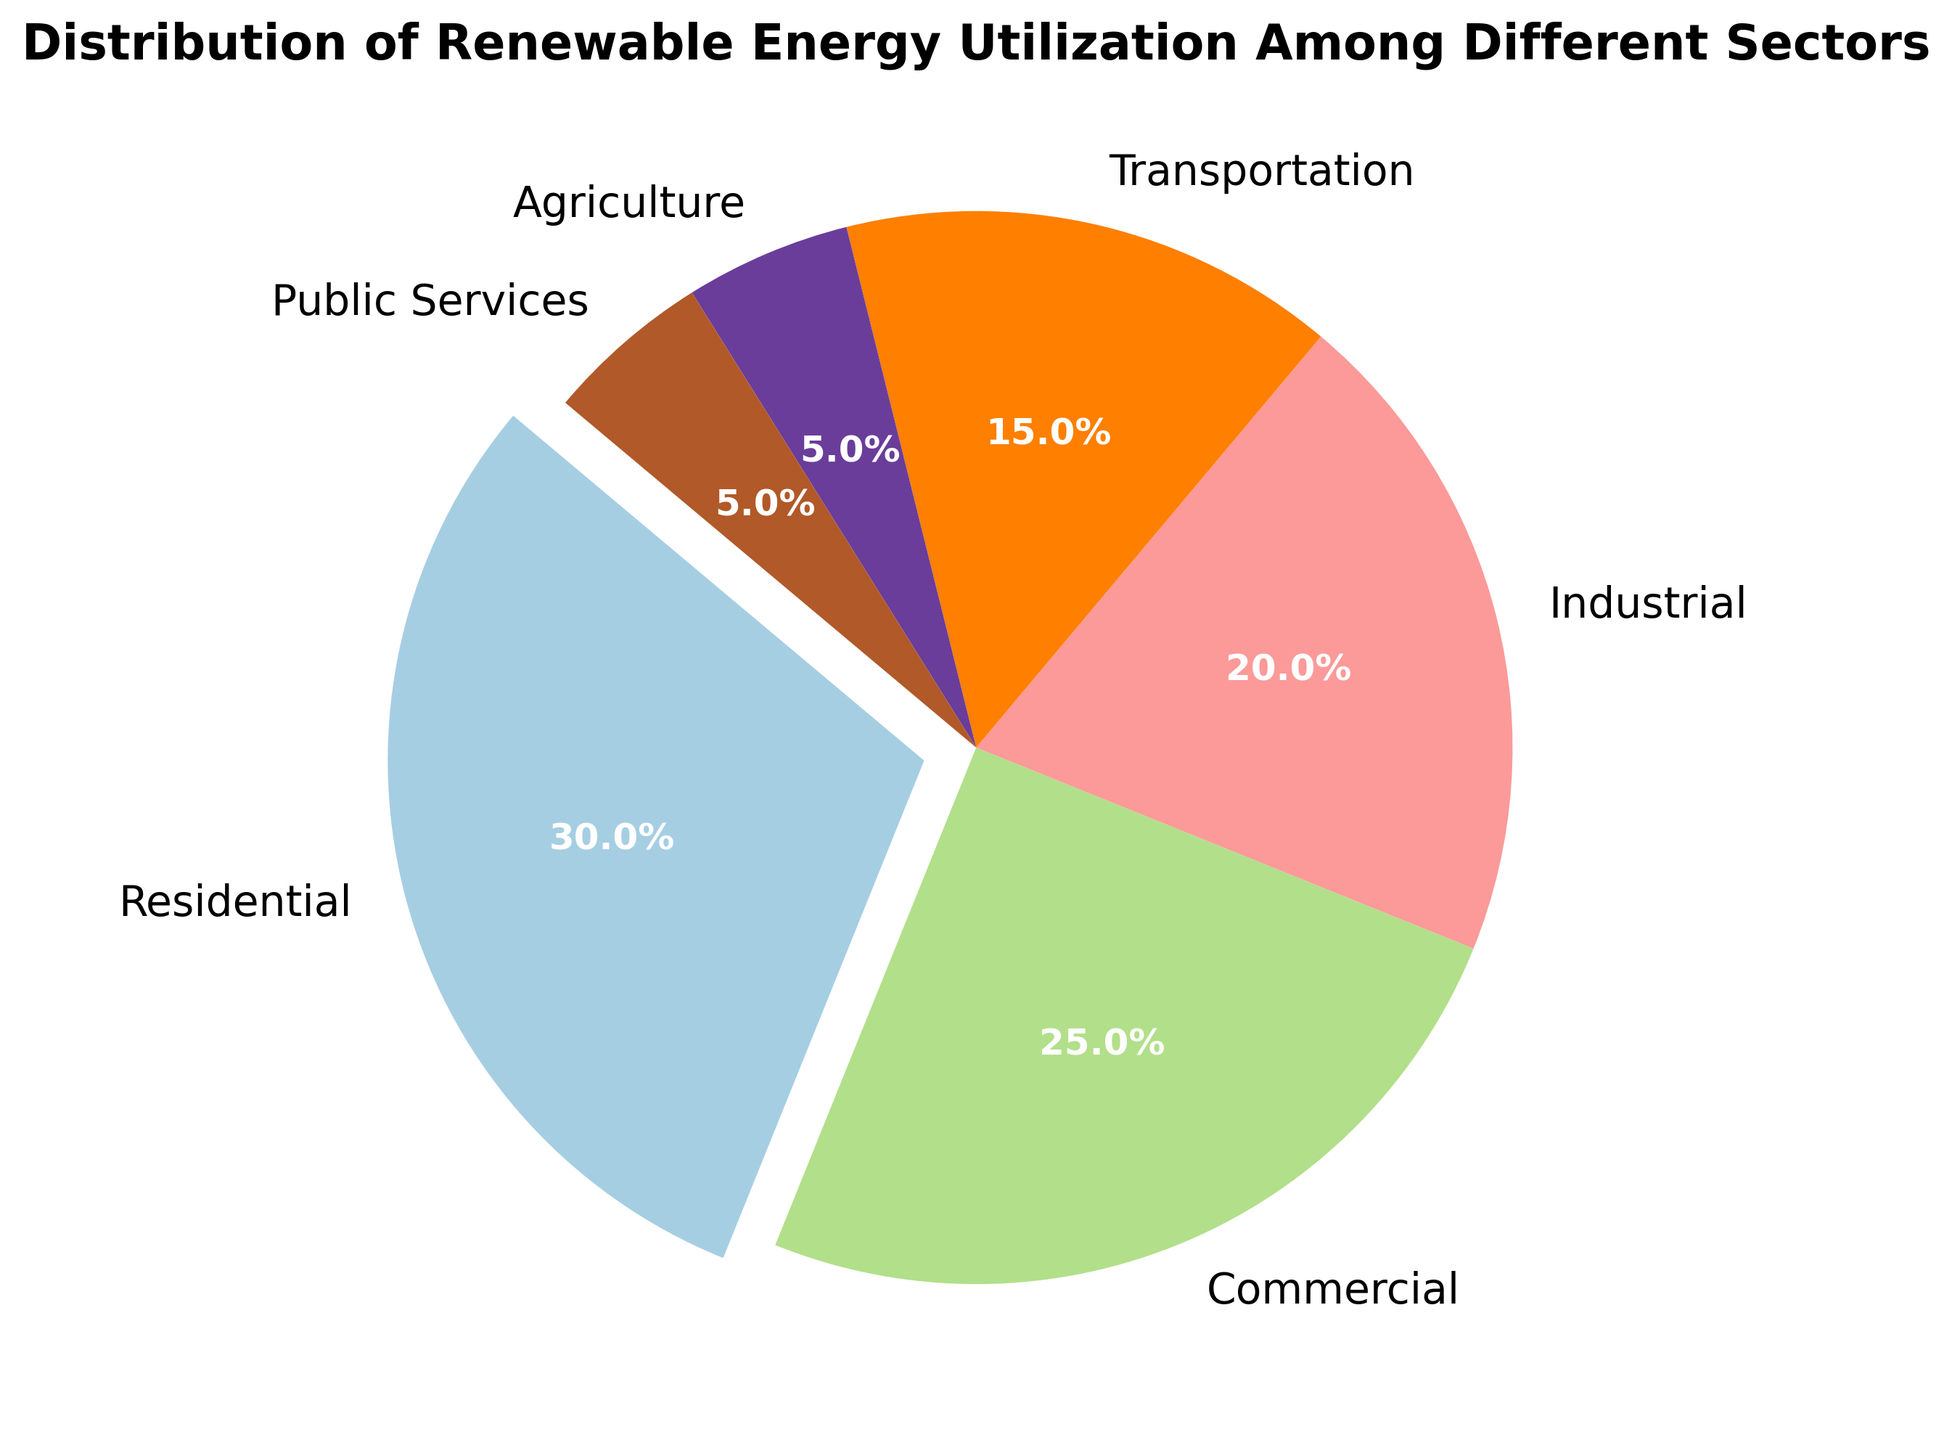What sector has the highest percentage of renewable energy utilization? By looking at the chart, the sector with the largest slice is Residential, which takes up 30% of the pie.
Answer: Residential What is the combined percentage of renewable energy utilization in the Residential and Commercial sectors? Add the percentages for Residential (30%) and Commercial (25%) which sums up to 55%.
Answer: 55% Which sector has a renewable energy utilization percentage equal to that of Public Services? Public Services has a utilization percentage of 5%. By looking at the pie chart, the Agriculture sector also has a utilization of 5%.
Answer: Agriculture What is the color associated with the Residential sector in the pie chart? The Residential sector has the largest slice of the pie chart, which is depicted in a specific color. From the pie chart, it's easy to identify this color visually.
Answer: the color representing Residential Rank the sectors in ascending order based on their renewable energy utilization percentages. By observing the sizes of the slices and the associated percentages, the order from smallest to largest is Agriculture (5%), Public Services (5%), Transportation (15%), Industrial (20%), Commercial (25%), and Residential (30%).
Answer: Agriculture, Public Services, Transportation, Industrial, Commercial, Residential How much more renewable energy does the Industrial sector use compared to the Agriculture sector? Subtract the percentage of the Agriculture sector (5%) from that of the Industrial sector (20%) to find the difference: 20% - 5% = 15%.
Answer: 15% Which sectors combined contribute to a third (33.3%) of the total renewable energy utilization? Identify sectors whose sum of percentages is close to one-third of the total. The combined percentages of Transportation (15%), Agriculture (5%), and Public Services (5%) add up to 25%. Including Industrial (20%) with any one of these sectors exceeds 33.3%. The best combination is Industrial (20%) and Transportation (15%), summing to 35%, which is slightly over one-third.
Answer: Industrial and Transportation How does the renewable energy utilization in Transportation compare to Commercial? By comparing their percentages, Transportation (15%) is less than Commercial (25%).
Answer: Transportation is less than Commercial What two sectors use exactly half of the renewable energy combined? Combine the percentages for different sectors to find a sum of 50%. The sectors Residential (30%) and Transportation (15%) plus Agriculture (5%) together equate to 50%.
Answer: Residential and Transportation + Agriculture 